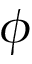Convert formula to latex. <formula><loc_0><loc_0><loc_500><loc_500>\phi</formula> 